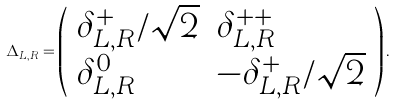<formula> <loc_0><loc_0><loc_500><loc_500>\Delta _ { L , R } = \left ( \begin{array} { l l } { { \delta _ { L , R } ^ { + } / \sqrt { 2 } } } & { { \delta _ { L , R } ^ { + + } } } \\ { { \delta _ { L , R } ^ { 0 } } } & { { - \delta _ { L , R } ^ { + } / \sqrt { 2 } } } \end{array} \right ) .</formula> 